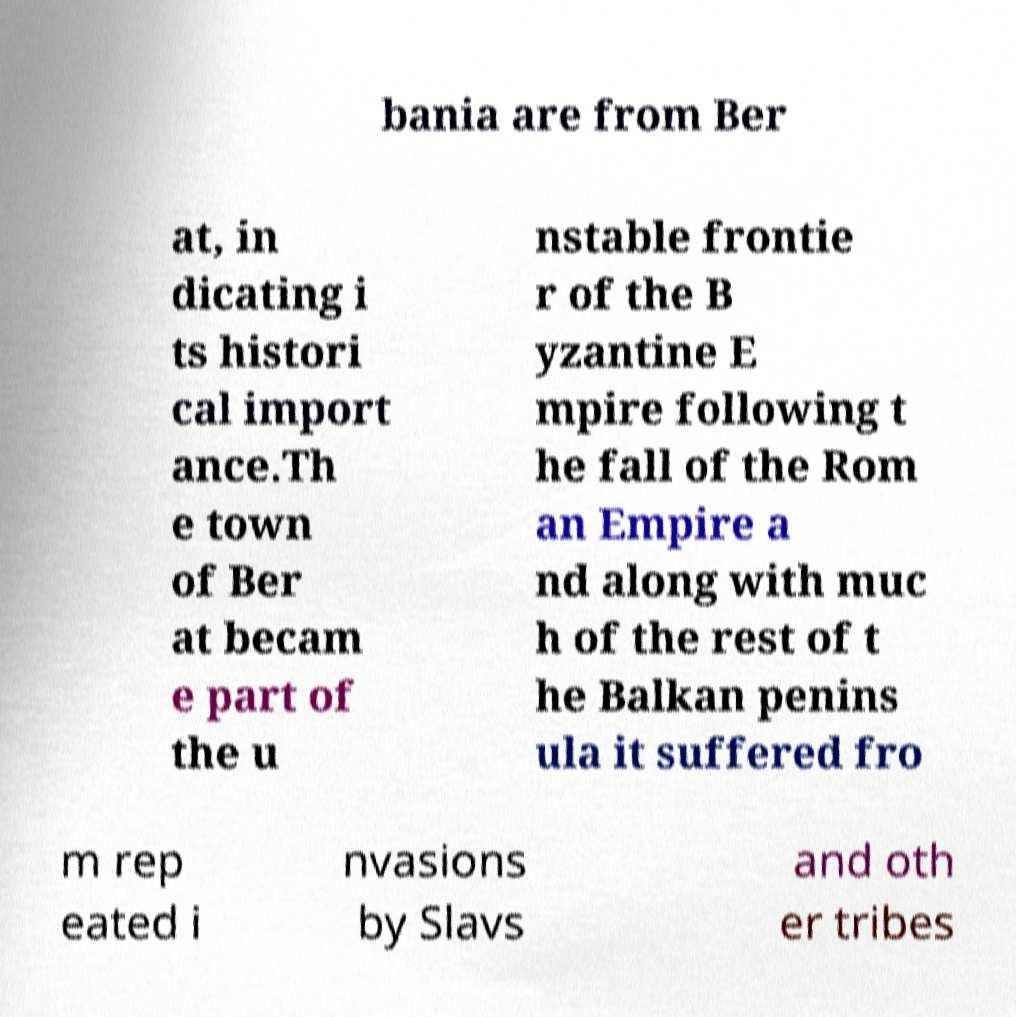Please read and relay the text visible in this image. What does it say? bania are from Ber at, in dicating i ts histori cal import ance.Th e town of Ber at becam e part of the u nstable frontie r of the B yzantine E mpire following t he fall of the Rom an Empire a nd along with muc h of the rest of t he Balkan penins ula it suffered fro m rep eated i nvasions by Slavs and oth er tribes 